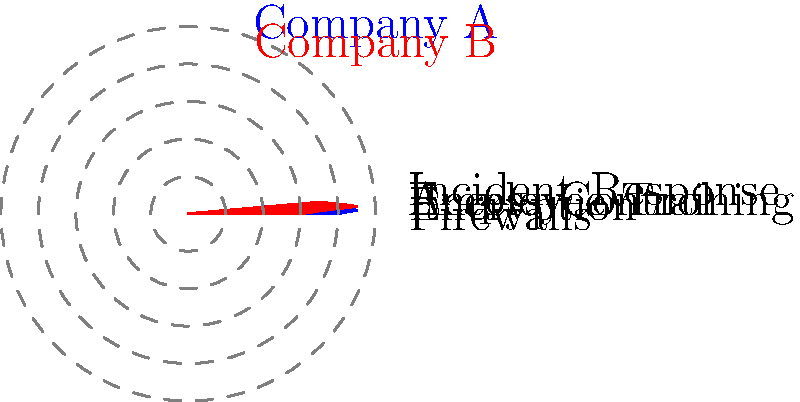Based on the radar chart comparing cybersecurity measures of two companies, which area shows the most significant difference in effectiveness between Company A and Company B? To answer this question, we need to analyze the radar chart step-by-step:

1. Identify the five cybersecurity measures being compared:
   - Firewalls
   - Encryption
   - Employee Training
   - Access Control
   - Incident Response

2. Compare the scores for each measure between Company A (blue) and Company B (red):
   - Firewalls: Company A (0.8) vs Company B (0.6)
   - Encryption: Company A (0.9) vs Company B (0.7)
   - Employee Training: Company A (0.7) vs Company B (0.9)
   - Access Control: Company A (0.6) vs Company B (0.8)
   - Incident Response: Company A (0.5) vs Company B (0.7)

3. Calculate the difference in scores for each measure:
   - Firewalls: 0.8 - 0.6 = 0.2
   - Encryption: 0.9 - 0.7 = 0.2
   - Employee Training: 0.7 - 0.9 = -0.2
   - Access Control: 0.6 - 0.8 = -0.2
   - Incident Response: 0.5 - 0.7 = -0.2

4. Identify the measure with the largest absolute difference:
   The absolute difference is 0.2 for all measures. However, the question asks for the most significant difference in effectiveness, which implies a directional difference.

5. Analyze the directional differences:
   - Firewalls and Encryption show Company A outperforming Company B.
   - Employee Training, Access Control, and Incident Response show Company B outperforming Company A.

6. Determine the most significant difference:
   Employee Training shows the most visually striking difference, with Company B significantly outperforming Company A in this area.
Answer: Employee Training 